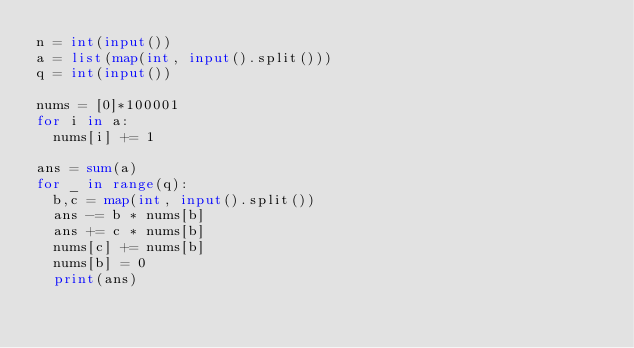Convert code to text. <code><loc_0><loc_0><loc_500><loc_500><_Python_>n = int(input())
a = list(map(int, input().split()))
q = int(input())

nums = [0]*100001
for i in a:
  nums[i] += 1

ans = sum(a)
for _ in range(q):
  b,c = map(int, input().split())
  ans -= b * nums[b]
  ans += c * nums[b]
  nums[c] += nums[b]
  nums[b] = 0
  print(ans)
</code> 